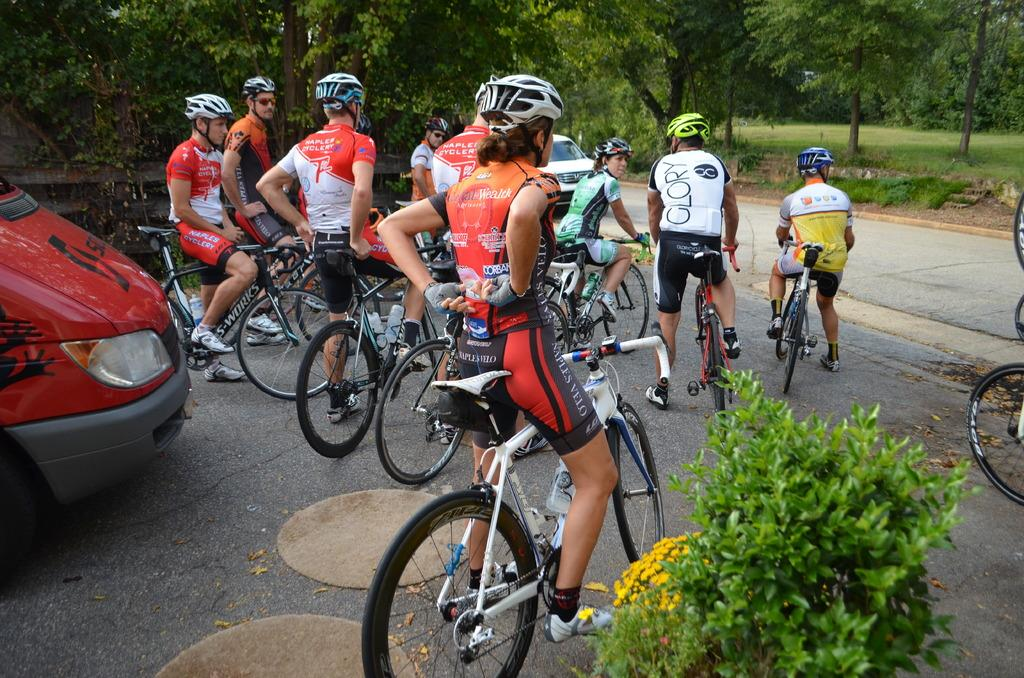What are the people in the image doing? The people in the image are sitting on bicycles. How are the people dressed in the image? The people are wearing different color dresses. What can be seen in the background of the image? There are trees in the background of the image. What type of vehicle is visible in the image? There is a red color car visible in the image. What type of disease can be seen affecting the trees in the image? There is no disease affecting the trees in the image; they appear healthy. Where is the drawer located in the image? There is no drawer present in the image. 